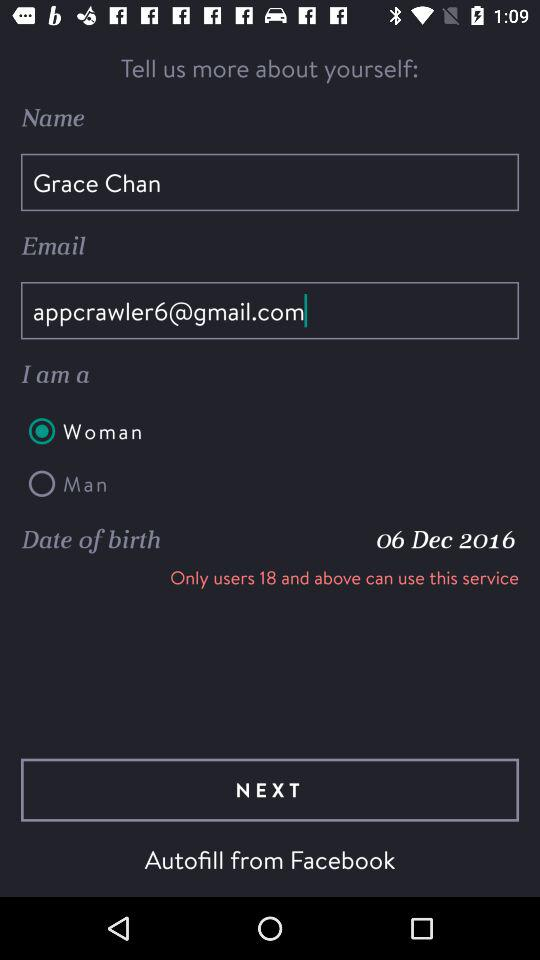Which gender is selected? The selected gender is woman. 